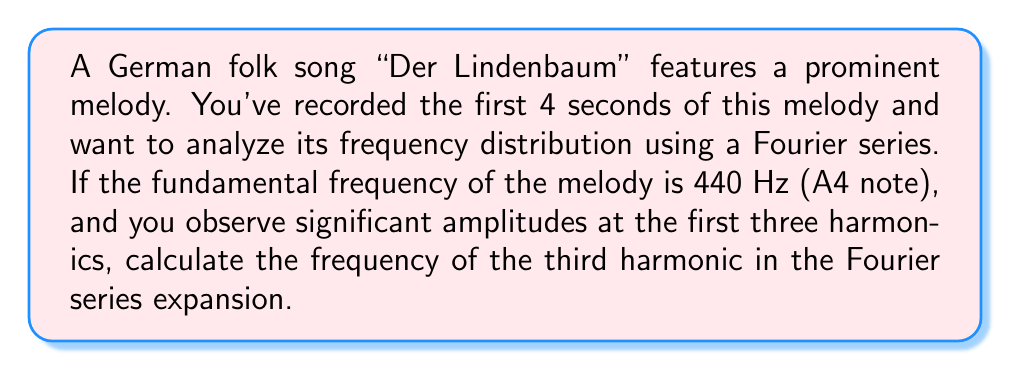Could you help me with this problem? Let's approach this step-by-step:

1) In a Fourier series, harmonics are integer multiples of the fundamental frequency. The fundamental frequency is also called the first harmonic.

2) Given:
   - Fundamental frequency (1st harmonic) = 440 Hz

3) To find the frequencies of the harmonics:
   - 2nd harmonic: $f_2 = 2 \times 440 = 880$ Hz
   - 3rd harmonic: $f_3 = 3 \times 440 = 1320$ Hz

4) The Fourier series for this melody can be represented as:

   $$f(t) = A_0 + \sum_{n=1}^{\infty} (A_n \cos(2\pi n f_0 t) + B_n \sin(2\pi n f_0 t))$$

   Where:
   - $f_0$ is the fundamental frequency (440 Hz)
   - $A_0$ is the DC component
   - $A_n$ and $B_n$ are the amplitudes of the cosine and sine terms
   - $n$ represents the harmonic number

5) The question asks specifically about the third harmonic, which corresponds to $n=3$ in the Fourier series.

6) Therefore, the frequency of the third harmonic is $3f_0 = 3 \times 440 = 1320$ Hz.
Answer: 1320 Hz 